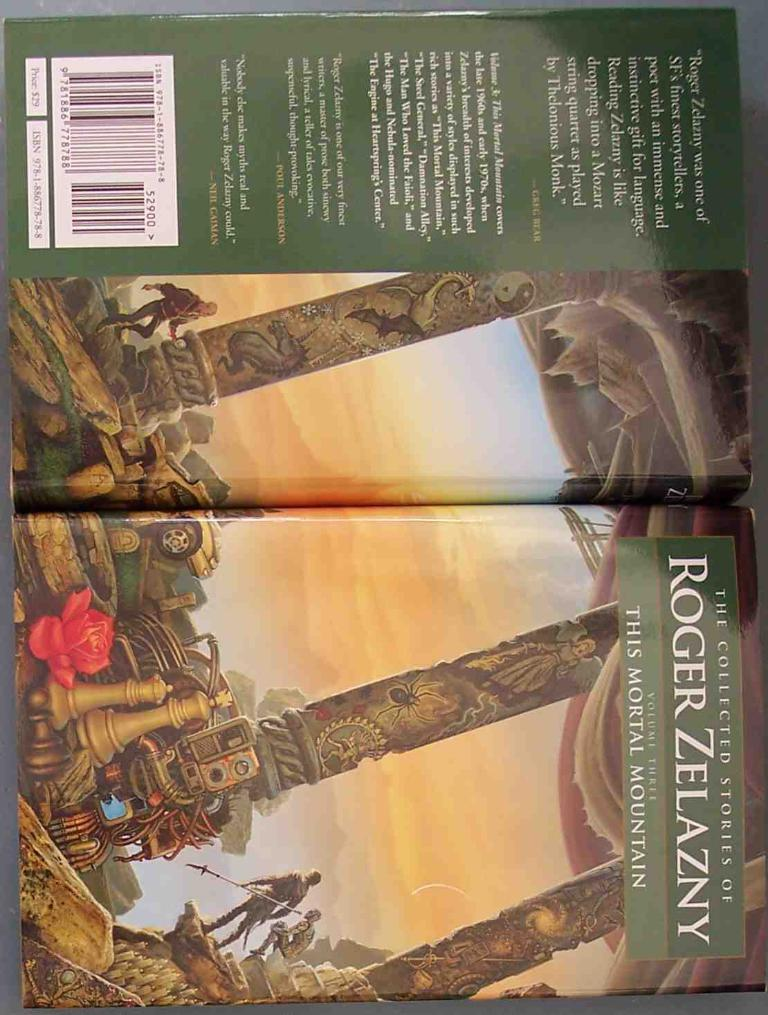<image>
Describe the image concisely. a book called 'this mortal mountain' by roger zelazny 